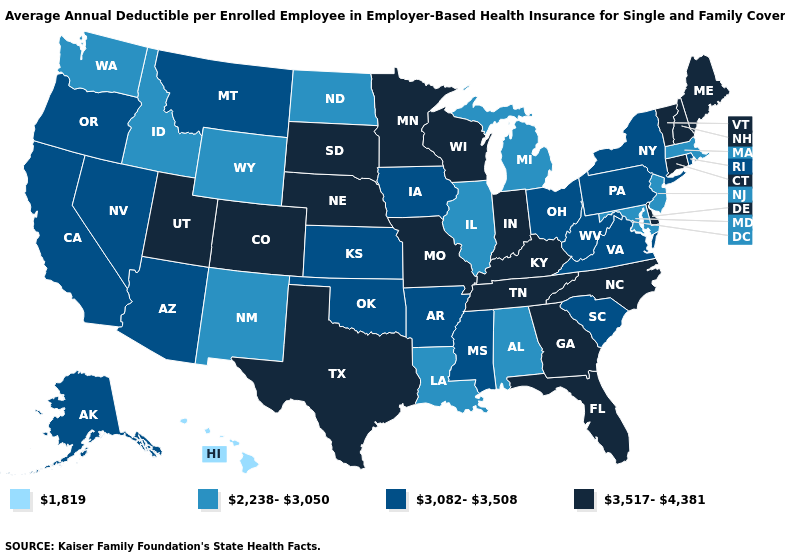What is the value of Arizona?
Keep it brief. 3,082-3,508. Among the states that border Louisiana , does Texas have the highest value?
Be succinct. Yes. Does Hawaii have the lowest value in the USA?
Be succinct. Yes. How many symbols are there in the legend?
Concise answer only. 4. Among the states that border New Jersey , which have the highest value?
Keep it brief. Delaware. Name the states that have a value in the range 1,819?
Answer briefly. Hawaii. Does Hawaii have the lowest value in the USA?
Quick response, please. Yes. Name the states that have a value in the range 3,517-4,381?
Quick response, please. Colorado, Connecticut, Delaware, Florida, Georgia, Indiana, Kentucky, Maine, Minnesota, Missouri, Nebraska, New Hampshire, North Carolina, South Dakota, Tennessee, Texas, Utah, Vermont, Wisconsin. Which states have the highest value in the USA?
Quick response, please. Colorado, Connecticut, Delaware, Florida, Georgia, Indiana, Kentucky, Maine, Minnesota, Missouri, Nebraska, New Hampshire, North Carolina, South Dakota, Tennessee, Texas, Utah, Vermont, Wisconsin. What is the highest value in states that border Tennessee?
Write a very short answer. 3,517-4,381. How many symbols are there in the legend?
Give a very brief answer. 4. Name the states that have a value in the range 2,238-3,050?
Write a very short answer. Alabama, Idaho, Illinois, Louisiana, Maryland, Massachusetts, Michigan, New Jersey, New Mexico, North Dakota, Washington, Wyoming. Name the states that have a value in the range 1,819?
Short answer required. Hawaii. Does Illinois have the lowest value in the MidWest?
Answer briefly. Yes. Does Wisconsin have a lower value than New Hampshire?
Short answer required. No. 